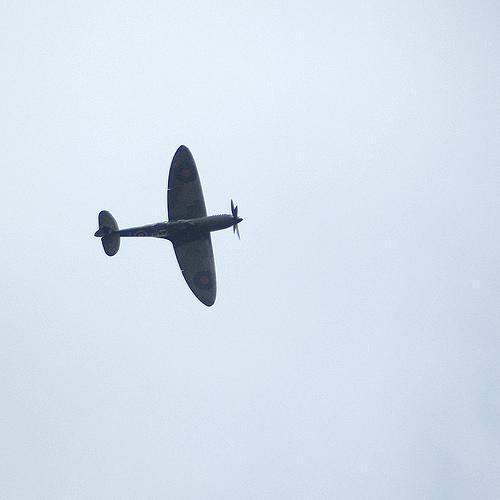How many wings are on the airplane?
Give a very brief answer. 2. 